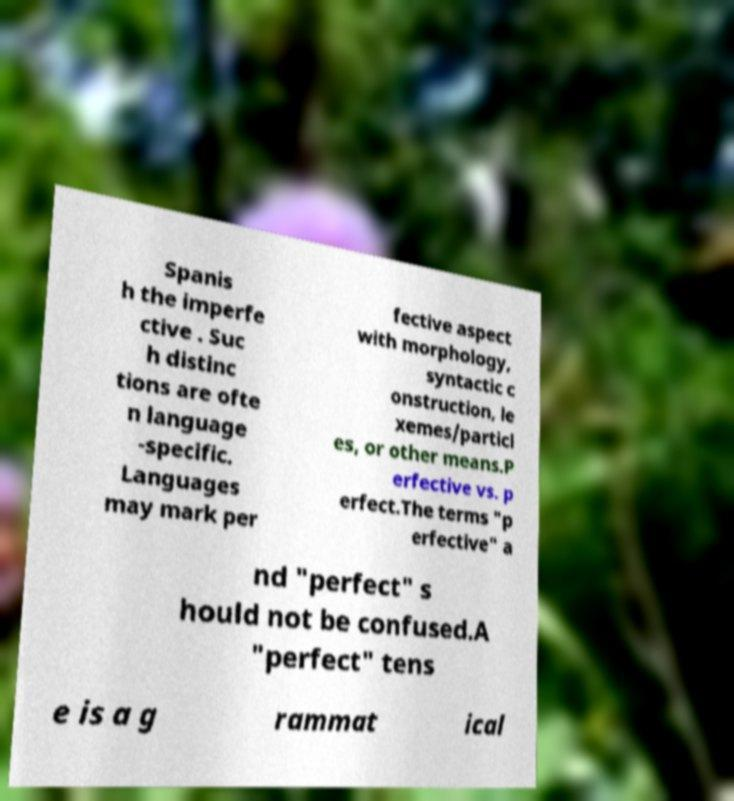What messages or text are displayed in this image? I need them in a readable, typed format. Spanis h the imperfe ctive . Suc h distinc tions are ofte n language -specific. Languages may mark per fective aspect with morphology, syntactic c onstruction, le xemes/particl es, or other means.P erfective vs. p erfect.The terms "p erfective" a nd "perfect" s hould not be confused.A "perfect" tens e is a g rammat ical 